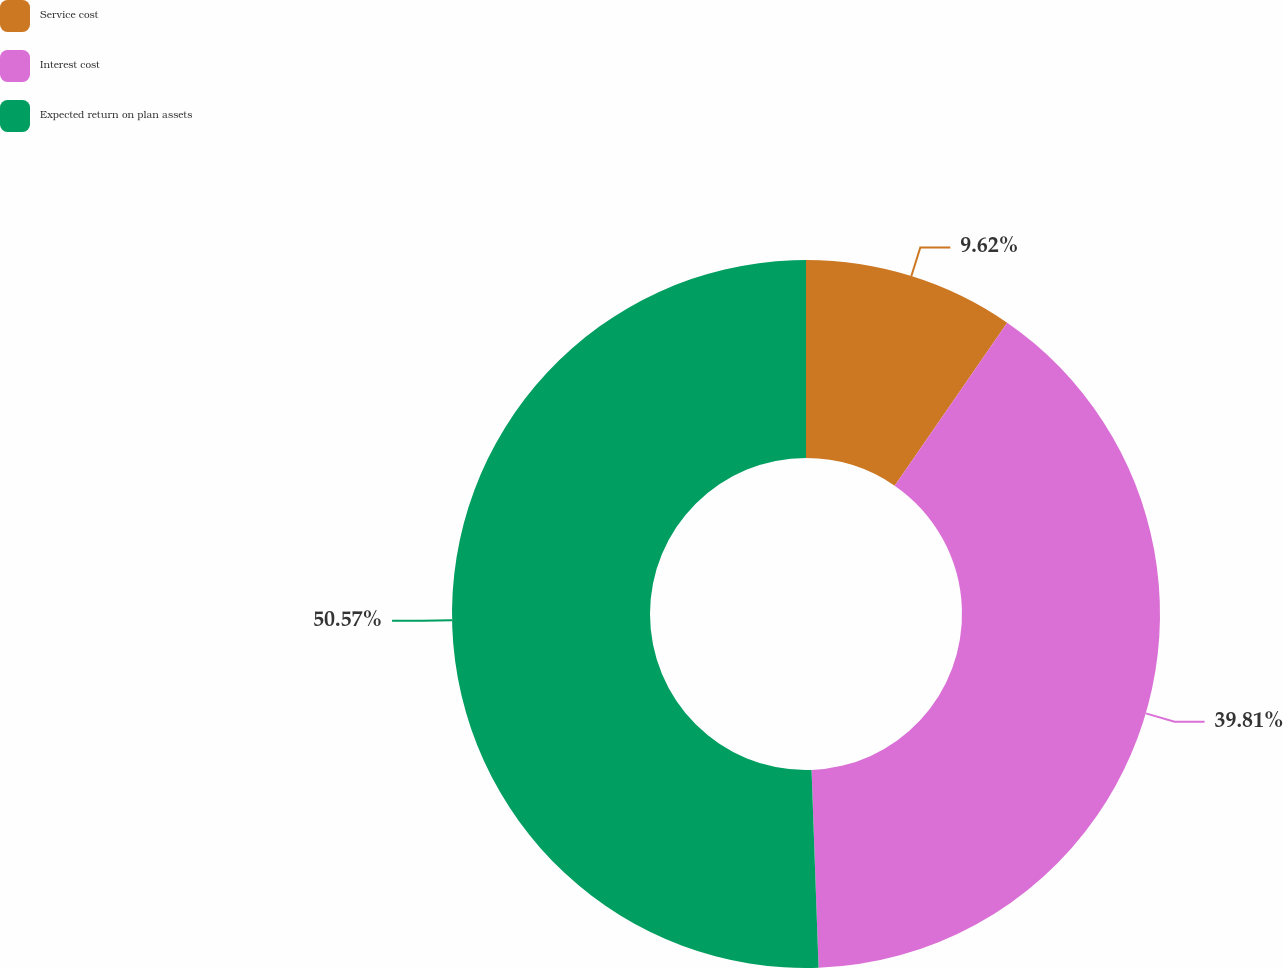<chart> <loc_0><loc_0><loc_500><loc_500><pie_chart><fcel>Service cost<fcel>Interest cost<fcel>Expected return on plan assets<nl><fcel>9.62%<fcel>39.81%<fcel>50.56%<nl></chart> 